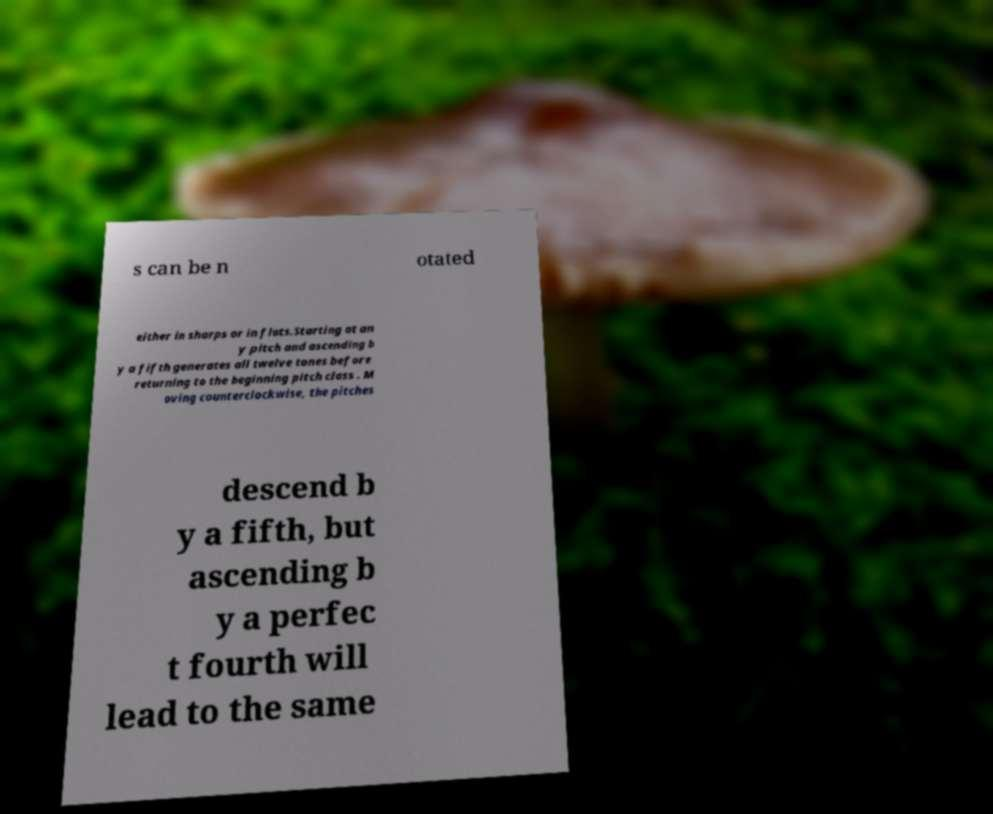Can you read and provide the text displayed in the image?This photo seems to have some interesting text. Can you extract and type it out for me? s can be n otated either in sharps or in flats.Starting at an y pitch and ascending b y a fifth generates all twelve tones before returning to the beginning pitch class . M oving counterclockwise, the pitches descend b y a fifth, but ascending b y a perfec t fourth will lead to the same 